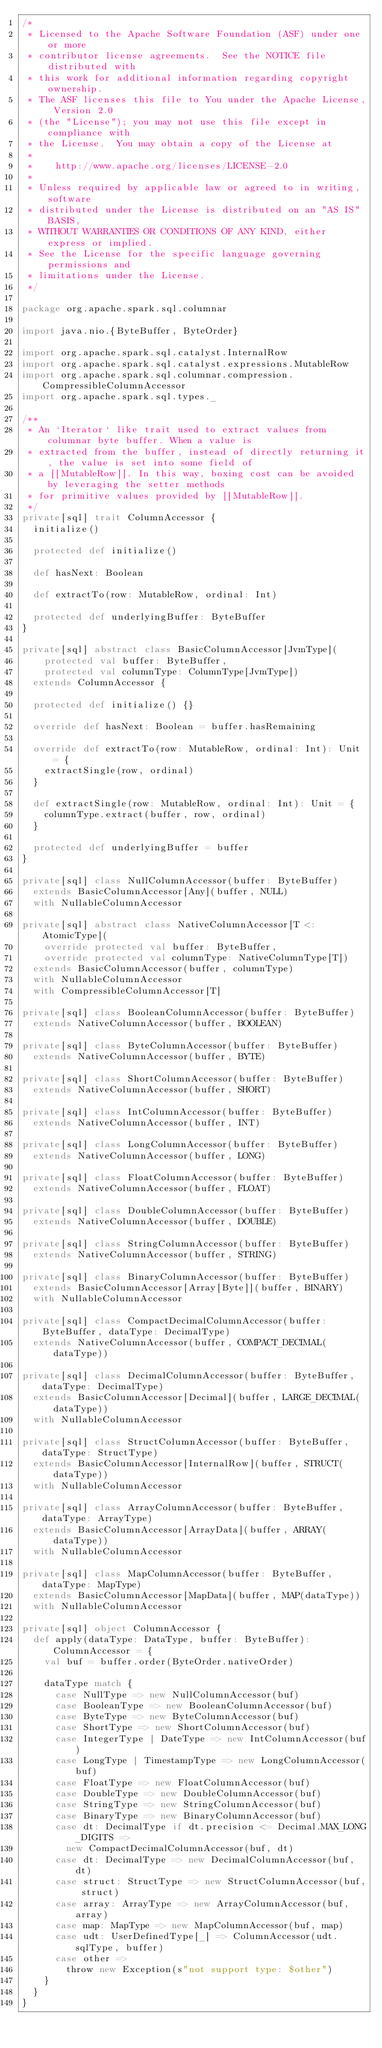Convert code to text. <code><loc_0><loc_0><loc_500><loc_500><_Scala_>/*
 * Licensed to the Apache Software Foundation (ASF) under one or more
 * contributor license agreements.  See the NOTICE file distributed with
 * this work for additional information regarding copyright ownership.
 * The ASF licenses this file to You under the Apache License, Version 2.0
 * (the "License"); you may not use this file except in compliance with
 * the License.  You may obtain a copy of the License at
 *
 *    http://www.apache.org/licenses/LICENSE-2.0
 *
 * Unless required by applicable law or agreed to in writing, software
 * distributed under the License is distributed on an "AS IS" BASIS,
 * WITHOUT WARRANTIES OR CONDITIONS OF ANY KIND, either express or implied.
 * See the License for the specific language governing permissions and
 * limitations under the License.
 */

package org.apache.spark.sql.columnar

import java.nio.{ByteBuffer, ByteOrder}

import org.apache.spark.sql.catalyst.InternalRow
import org.apache.spark.sql.catalyst.expressions.MutableRow
import org.apache.spark.sql.columnar.compression.CompressibleColumnAccessor
import org.apache.spark.sql.types._

/**
 * An `Iterator` like trait used to extract values from columnar byte buffer. When a value is
 * extracted from the buffer, instead of directly returning it, the value is set into some field of
 * a [[MutableRow]]. In this way, boxing cost can be avoided by leveraging the setter methods
 * for primitive values provided by [[MutableRow]].
 */
private[sql] trait ColumnAccessor {
  initialize()

  protected def initialize()

  def hasNext: Boolean

  def extractTo(row: MutableRow, ordinal: Int)

  protected def underlyingBuffer: ByteBuffer
}

private[sql] abstract class BasicColumnAccessor[JvmType](
    protected val buffer: ByteBuffer,
    protected val columnType: ColumnType[JvmType])
  extends ColumnAccessor {

  protected def initialize() {}

  override def hasNext: Boolean = buffer.hasRemaining

  override def extractTo(row: MutableRow, ordinal: Int): Unit = {
    extractSingle(row, ordinal)
  }

  def extractSingle(row: MutableRow, ordinal: Int): Unit = {
    columnType.extract(buffer, row, ordinal)
  }

  protected def underlyingBuffer = buffer
}

private[sql] class NullColumnAccessor(buffer: ByteBuffer)
  extends BasicColumnAccessor[Any](buffer, NULL)
  with NullableColumnAccessor

private[sql] abstract class NativeColumnAccessor[T <: AtomicType](
    override protected val buffer: ByteBuffer,
    override protected val columnType: NativeColumnType[T])
  extends BasicColumnAccessor(buffer, columnType)
  with NullableColumnAccessor
  with CompressibleColumnAccessor[T]

private[sql] class BooleanColumnAccessor(buffer: ByteBuffer)
  extends NativeColumnAccessor(buffer, BOOLEAN)

private[sql] class ByteColumnAccessor(buffer: ByteBuffer)
  extends NativeColumnAccessor(buffer, BYTE)

private[sql] class ShortColumnAccessor(buffer: ByteBuffer)
  extends NativeColumnAccessor(buffer, SHORT)

private[sql] class IntColumnAccessor(buffer: ByteBuffer)
  extends NativeColumnAccessor(buffer, INT)

private[sql] class LongColumnAccessor(buffer: ByteBuffer)
  extends NativeColumnAccessor(buffer, LONG)

private[sql] class FloatColumnAccessor(buffer: ByteBuffer)
  extends NativeColumnAccessor(buffer, FLOAT)

private[sql] class DoubleColumnAccessor(buffer: ByteBuffer)
  extends NativeColumnAccessor(buffer, DOUBLE)

private[sql] class StringColumnAccessor(buffer: ByteBuffer)
  extends NativeColumnAccessor(buffer, STRING)

private[sql] class BinaryColumnAccessor(buffer: ByteBuffer)
  extends BasicColumnAccessor[Array[Byte]](buffer, BINARY)
  with NullableColumnAccessor

private[sql] class CompactDecimalColumnAccessor(buffer: ByteBuffer, dataType: DecimalType)
  extends NativeColumnAccessor(buffer, COMPACT_DECIMAL(dataType))

private[sql] class DecimalColumnAccessor(buffer: ByteBuffer, dataType: DecimalType)
  extends BasicColumnAccessor[Decimal](buffer, LARGE_DECIMAL(dataType))
  with NullableColumnAccessor

private[sql] class StructColumnAccessor(buffer: ByteBuffer, dataType: StructType)
  extends BasicColumnAccessor[InternalRow](buffer, STRUCT(dataType))
  with NullableColumnAccessor

private[sql] class ArrayColumnAccessor(buffer: ByteBuffer, dataType: ArrayType)
  extends BasicColumnAccessor[ArrayData](buffer, ARRAY(dataType))
  with NullableColumnAccessor

private[sql] class MapColumnAccessor(buffer: ByteBuffer, dataType: MapType)
  extends BasicColumnAccessor[MapData](buffer, MAP(dataType))
  with NullableColumnAccessor

private[sql] object ColumnAccessor {
  def apply(dataType: DataType, buffer: ByteBuffer): ColumnAccessor = {
    val buf = buffer.order(ByteOrder.nativeOrder)

    dataType match {
      case NullType => new NullColumnAccessor(buf)
      case BooleanType => new BooleanColumnAccessor(buf)
      case ByteType => new ByteColumnAccessor(buf)
      case ShortType => new ShortColumnAccessor(buf)
      case IntegerType | DateType => new IntColumnAccessor(buf)
      case LongType | TimestampType => new LongColumnAccessor(buf)
      case FloatType => new FloatColumnAccessor(buf)
      case DoubleType => new DoubleColumnAccessor(buf)
      case StringType => new StringColumnAccessor(buf)
      case BinaryType => new BinaryColumnAccessor(buf)
      case dt: DecimalType if dt.precision <= Decimal.MAX_LONG_DIGITS =>
        new CompactDecimalColumnAccessor(buf, dt)
      case dt: DecimalType => new DecimalColumnAccessor(buf, dt)
      case struct: StructType => new StructColumnAccessor(buf, struct)
      case array: ArrayType => new ArrayColumnAccessor(buf, array)
      case map: MapType => new MapColumnAccessor(buf, map)
      case udt: UserDefinedType[_] => ColumnAccessor(udt.sqlType, buffer)
      case other =>
        throw new Exception(s"not support type: $other")
    }
  }
}
</code> 